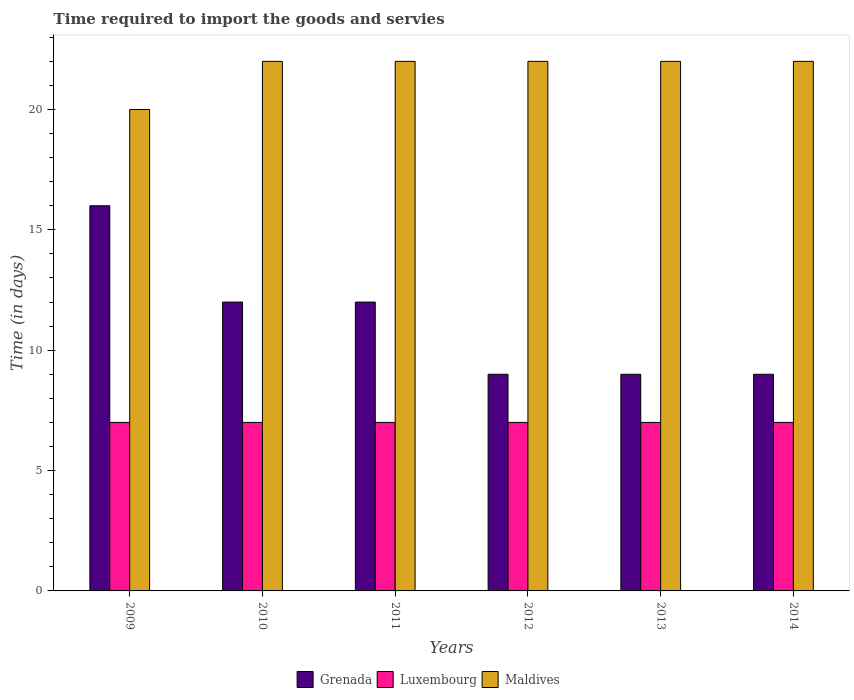How many groups of bars are there?
Your answer should be compact. 6. Are the number of bars per tick equal to the number of legend labels?
Your answer should be compact. Yes. How many bars are there on the 4th tick from the left?
Ensure brevity in your answer.  3. What is the label of the 6th group of bars from the left?
Your answer should be very brief. 2014. Across all years, what is the maximum number of days required to import the goods and services in Maldives?
Give a very brief answer. 22. Across all years, what is the minimum number of days required to import the goods and services in Luxembourg?
Make the answer very short. 7. What is the total number of days required to import the goods and services in Grenada in the graph?
Your response must be concise. 67. What is the difference between the number of days required to import the goods and services in Grenada in 2010 and that in 2014?
Keep it short and to the point. 3. What is the difference between the number of days required to import the goods and services in Grenada in 2014 and the number of days required to import the goods and services in Maldives in 2013?
Your response must be concise. -13. What is the average number of days required to import the goods and services in Maldives per year?
Your response must be concise. 21.67. In how many years, is the number of days required to import the goods and services in Grenada greater than 19 days?
Make the answer very short. 0. What is the difference between the highest and the second highest number of days required to import the goods and services in Maldives?
Provide a short and direct response. 0. What is the difference between the highest and the lowest number of days required to import the goods and services in Grenada?
Ensure brevity in your answer.  7. Is the sum of the number of days required to import the goods and services in Maldives in 2010 and 2013 greater than the maximum number of days required to import the goods and services in Luxembourg across all years?
Provide a succinct answer. Yes. What does the 3rd bar from the left in 2009 represents?
Ensure brevity in your answer.  Maldives. What does the 2nd bar from the right in 2010 represents?
Keep it short and to the point. Luxembourg. Are all the bars in the graph horizontal?
Offer a terse response. No. Are the values on the major ticks of Y-axis written in scientific E-notation?
Provide a short and direct response. No. Does the graph contain any zero values?
Keep it short and to the point. No. Does the graph contain grids?
Keep it short and to the point. No. Where does the legend appear in the graph?
Make the answer very short. Bottom center. How are the legend labels stacked?
Ensure brevity in your answer.  Horizontal. What is the title of the graph?
Offer a terse response. Time required to import the goods and servies. What is the label or title of the Y-axis?
Keep it short and to the point. Time (in days). What is the Time (in days) of Luxembourg in 2009?
Provide a short and direct response. 7. What is the Time (in days) in Grenada in 2011?
Provide a succinct answer. 12. What is the Time (in days) of Luxembourg in 2011?
Make the answer very short. 7. What is the Time (in days) in Maldives in 2011?
Your response must be concise. 22. What is the Time (in days) of Grenada in 2012?
Ensure brevity in your answer.  9. What is the Time (in days) in Maldives in 2012?
Offer a very short reply. 22. What is the Time (in days) of Grenada in 2013?
Offer a terse response. 9. What is the Time (in days) in Maldives in 2013?
Ensure brevity in your answer.  22. What is the Time (in days) in Grenada in 2014?
Offer a very short reply. 9. What is the Time (in days) of Luxembourg in 2014?
Your response must be concise. 7. What is the Time (in days) in Maldives in 2014?
Offer a very short reply. 22. Across all years, what is the maximum Time (in days) of Luxembourg?
Your response must be concise. 7. Across all years, what is the maximum Time (in days) in Maldives?
Give a very brief answer. 22. Across all years, what is the minimum Time (in days) of Luxembourg?
Offer a very short reply. 7. Across all years, what is the minimum Time (in days) in Maldives?
Give a very brief answer. 20. What is the total Time (in days) of Maldives in the graph?
Offer a very short reply. 130. What is the difference between the Time (in days) of Luxembourg in 2009 and that in 2010?
Give a very brief answer. 0. What is the difference between the Time (in days) in Grenada in 2009 and that in 2011?
Give a very brief answer. 4. What is the difference between the Time (in days) in Luxembourg in 2009 and that in 2011?
Ensure brevity in your answer.  0. What is the difference between the Time (in days) of Maldives in 2009 and that in 2011?
Provide a succinct answer. -2. What is the difference between the Time (in days) of Luxembourg in 2009 and that in 2012?
Offer a very short reply. 0. What is the difference between the Time (in days) of Maldives in 2009 and that in 2012?
Provide a short and direct response. -2. What is the difference between the Time (in days) in Maldives in 2009 and that in 2013?
Your answer should be very brief. -2. What is the difference between the Time (in days) of Luxembourg in 2009 and that in 2014?
Your response must be concise. 0. What is the difference between the Time (in days) in Maldives in 2009 and that in 2014?
Offer a terse response. -2. What is the difference between the Time (in days) of Grenada in 2010 and that in 2011?
Give a very brief answer. 0. What is the difference between the Time (in days) in Grenada in 2010 and that in 2012?
Offer a terse response. 3. What is the difference between the Time (in days) of Grenada in 2010 and that in 2013?
Your response must be concise. 3. What is the difference between the Time (in days) in Maldives in 2010 and that in 2013?
Give a very brief answer. 0. What is the difference between the Time (in days) in Grenada in 2010 and that in 2014?
Offer a terse response. 3. What is the difference between the Time (in days) of Luxembourg in 2010 and that in 2014?
Provide a succinct answer. 0. What is the difference between the Time (in days) in Maldives in 2010 and that in 2014?
Offer a terse response. 0. What is the difference between the Time (in days) in Grenada in 2011 and that in 2013?
Provide a succinct answer. 3. What is the difference between the Time (in days) of Maldives in 2011 and that in 2013?
Keep it short and to the point. 0. What is the difference between the Time (in days) of Grenada in 2011 and that in 2014?
Provide a short and direct response. 3. What is the difference between the Time (in days) of Luxembourg in 2011 and that in 2014?
Keep it short and to the point. 0. What is the difference between the Time (in days) of Grenada in 2012 and that in 2014?
Your response must be concise. 0. What is the difference between the Time (in days) in Luxembourg in 2012 and that in 2014?
Your answer should be compact. 0. What is the difference between the Time (in days) in Grenada in 2013 and that in 2014?
Provide a succinct answer. 0. What is the difference between the Time (in days) in Grenada in 2009 and the Time (in days) in Maldives in 2010?
Provide a short and direct response. -6. What is the difference between the Time (in days) in Grenada in 2009 and the Time (in days) in Maldives in 2011?
Provide a short and direct response. -6. What is the difference between the Time (in days) of Grenada in 2009 and the Time (in days) of Maldives in 2012?
Provide a succinct answer. -6. What is the difference between the Time (in days) in Luxembourg in 2009 and the Time (in days) in Maldives in 2012?
Make the answer very short. -15. What is the difference between the Time (in days) of Grenada in 2009 and the Time (in days) of Maldives in 2013?
Ensure brevity in your answer.  -6. What is the difference between the Time (in days) of Grenada in 2009 and the Time (in days) of Maldives in 2014?
Your answer should be very brief. -6. What is the difference between the Time (in days) of Grenada in 2010 and the Time (in days) of Luxembourg in 2011?
Provide a succinct answer. 5. What is the difference between the Time (in days) of Luxembourg in 2010 and the Time (in days) of Maldives in 2011?
Your response must be concise. -15. What is the difference between the Time (in days) in Grenada in 2010 and the Time (in days) in Maldives in 2012?
Your response must be concise. -10. What is the difference between the Time (in days) of Luxembourg in 2010 and the Time (in days) of Maldives in 2012?
Ensure brevity in your answer.  -15. What is the difference between the Time (in days) in Grenada in 2010 and the Time (in days) in Luxembourg in 2013?
Ensure brevity in your answer.  5. What is the difference between the Time (in days) of Luxembourg in 2010 and the Time (in days) of Maldives in 2013?
Provide a short and direct response. -15. What is the difference between the Time (in days) of Grenada in 2011 and the Time (in days) of Luxembourg in 2012?
Keep it short and to the point. 5. What is the difference between the Time (in days) in Grenada in 2011 and the Time (in days) in Maldives in 2012?
Offer a very short reply. -10. What is the difference between the Time (in days) in Grenada in 2011 and the Time (in days) in Luxembourg in 2013?
Provide a succinct answer. 5. What is the difference between the Time (in days) in Grenada in 2011 and the Time (in days) in Maldives in 2013?
Ensure brevity in your answer.  -10. What is the difference between the Time (in days) of Grenada in 2011 and the Time (in days) of Luxembourg in 2014?
Provide a succinct answer. 5. What is the difference between the Time (in days) in Grenada in 2011 and the Time (in days) in Maldives in 2014?
Offer a very short reply. -10. What is the difference between the Time (in days) of Grenada in 2012 and the Time (in days) of Luxembourg in 2013?
Ensure brevity in your answer.  2. What is the difference between the Time (in days) of Luxembourg in 2012 and the Time (in days) of Maldives in 2013?
Provide a short and direct response. -15. What is the difference between the Time (in days) of Grenada in 2012 and the Time (in days) of Luxembourg in 2014?
Ensure brevity in your answer.  2. What is the difference between the Time (in days) of Luxembourg in 2012 and the Time (in days) of Maldives in 2014?
Your answer should be very brief. -15. What is the difference between the Time (in days) in Luxembourg in 2013 and the Time (in days) in Maldives in 2014?
Offer a terse response. -15. What is the average Time (in days) of Grenada per year?
Provide a short and direct response. 11.17. What is the average Time (in days) in Maldives per year?
Your answer should be compact. 21.67. In the year 2009, what is the difference between the Time (in days) of Grenada and Time (in days) of Luxembourg?
Provide a short and direct response. 9. In the year 2010, what is the difference between the Time (in days) of Grenada and Time (in days) of Maldives?
Ensure brevity in your answer.  -10. In the year 2011, what is the difference between the Time (in days) in Grenada and Time (in days) in Luxembourg?
Give a very brief answer. 5. In the year 2011, what is the difference between the Time (in days) of Grenada and Time (in days) of Maldives?
Give a very brief answer. -10. In the year 2012, what is the difference between the Time (in days) in Grenada and Time (in days) in Luxembourg?
Offer a very short reply. 2. In the year 2012, what is the difference between the Time (in days) of Grenada and Time (in days) of Maldives?
Ensure brevity in your answer.  -13. In the year 2013, what is the difference between the Time (in days) in Grenada and Time (in days) in Luxembourg?
Offer a very short reply. 2. In the year 2013, what is the difference between the Time (in days) in Grenada and Time (in days) in Maldives?
Your answer should be very brief. -13. In the year 2014, what is the difference between the Time (in days) of Grenada and Time (in days) of Maldives?
Your answer should be compact. -13. What is the ratio of the Time (in days) in Grenada in 2009 to that in 2011?
Keep it short and to the point. 1.33. What is the ratio of the Time (in days) in Luxembourg in 2009 to that in 2011?
Your answer should be compact. 1. What is the ratio of the Time (in days) in Maldives in 2009 to that in 2011?
Ensure brevity in your answer.  0.91. What is the ratio of the Time (in days) in Grenada in 2009 to that in 2012?
Offer a very short reply. 1.78. What is the ratio of the Time (in days) in Luxembourg in 2009 to that in 2012?
Give a very brief answer. 1. What is the ratio of the Time (in days) in Grenada in 2009 to that in 2013?
Offer a very short reply. 1.78. What is the ratio of the Time (in days) of Grenada in 2009 to that in 2014?
Offer a very short reply. 1.78. What is the ratio of the Time (in days) in Luxembourg in 2009 to that in 2014?
Make the answer very short. 1. What is the ratio of the Time (in days) of Grenada in 2010 to that in 2011?
Give a very brief answer. 1. What is the ratio of the Time (in days) of Maldives in 2010 to that in 2011?
Provide a succinct answer. 1. What is the ratio of the Time (in days) in Grenada in 2010 to that in 2012?
Provide a short and direct response. 1.33. What is the ratio of the Time (in days) in Luxembourg in 2010 to that in 2012?
Give a very brief answer. 1. What is the ratio of the Time (in days) in Maldives in 2010 to that in 2012?
Keep it short and to the point. 1. What is the ratio of the Time (in days) of Luxembourg in 2010 to that in 2013?
Provide a short and direct response. 1. What is the ratio of the Time (in days) of Maldives in 2011 to that in 2012?
Ensure brevity in your answer.  1. What is the ratio of the Time (in days) of Luxembourg in 2011 to that in 2013?
Your response must be concise. 1. What is the ratio of the Time (in days) in Maldives in 2011 to that in 2013?
Provide a succinct answer. 1. What is the ratio of the Time (in days) in Maldives in 2011 to that in 2014?
Your response must be concise. 1. What is the ratio of the Time (in days) in Grenada in 2012 to that in 2013?
Ensure brevity in your answer.  1. What is the ratio of the Time (in days) in Luxembourg in 2012 to that in 2013?
Make the answer very short. 1. What is the ratio of the Time (in days) of Maldives in 2012 to that in 2013?
Your response must be concise. 1. What is the ratio of the Time (in days) in Grenada in 2012 to that in 2014?
Offer a very short reply. 1. What is the ratio of the Time (in days) in Luxembourg in 2013 to that in 2014?
Provide a succinct answer. 1. What is the difference between the highest and the second highest Time (in days) in Luxembourg?
Offer a very short reply. 0. What is the difference between the highest and the lowest Time (in days) in Maldives?
Make the answer very short. 2. 